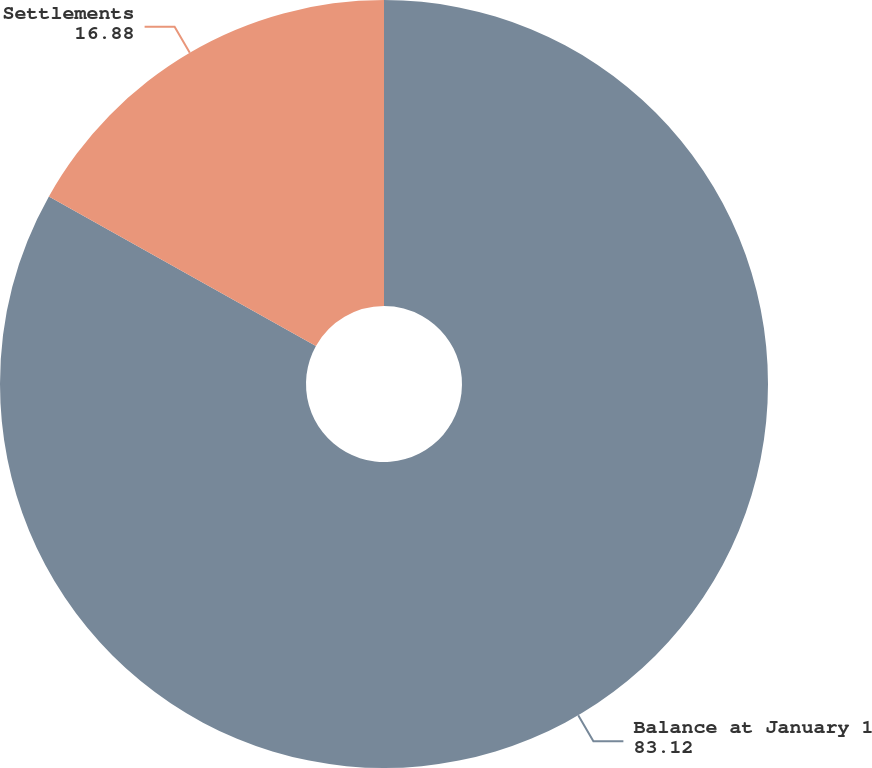Convert chart to OTSL. <chart><loc_0><loc_0><loc_500><loc_500><pie_chart><fcel>Balance at January 1<fcel>Settlements<nl><fcel>83.12%<fcel>16.88%<nl></chart> 